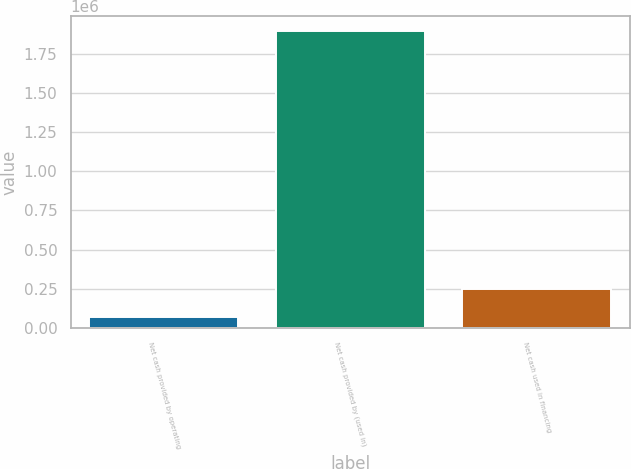Convert chart. <chart><loc_0><loc_0><loc_500><loc_500><bar_chart><fcel>Net cash provided by operating<fcel>Net cash provided by (used in)<fcel>Net cash used in financing<nl><fcel>68470<fcel>1.89261e+06<fcel>250884<nl></chart> 